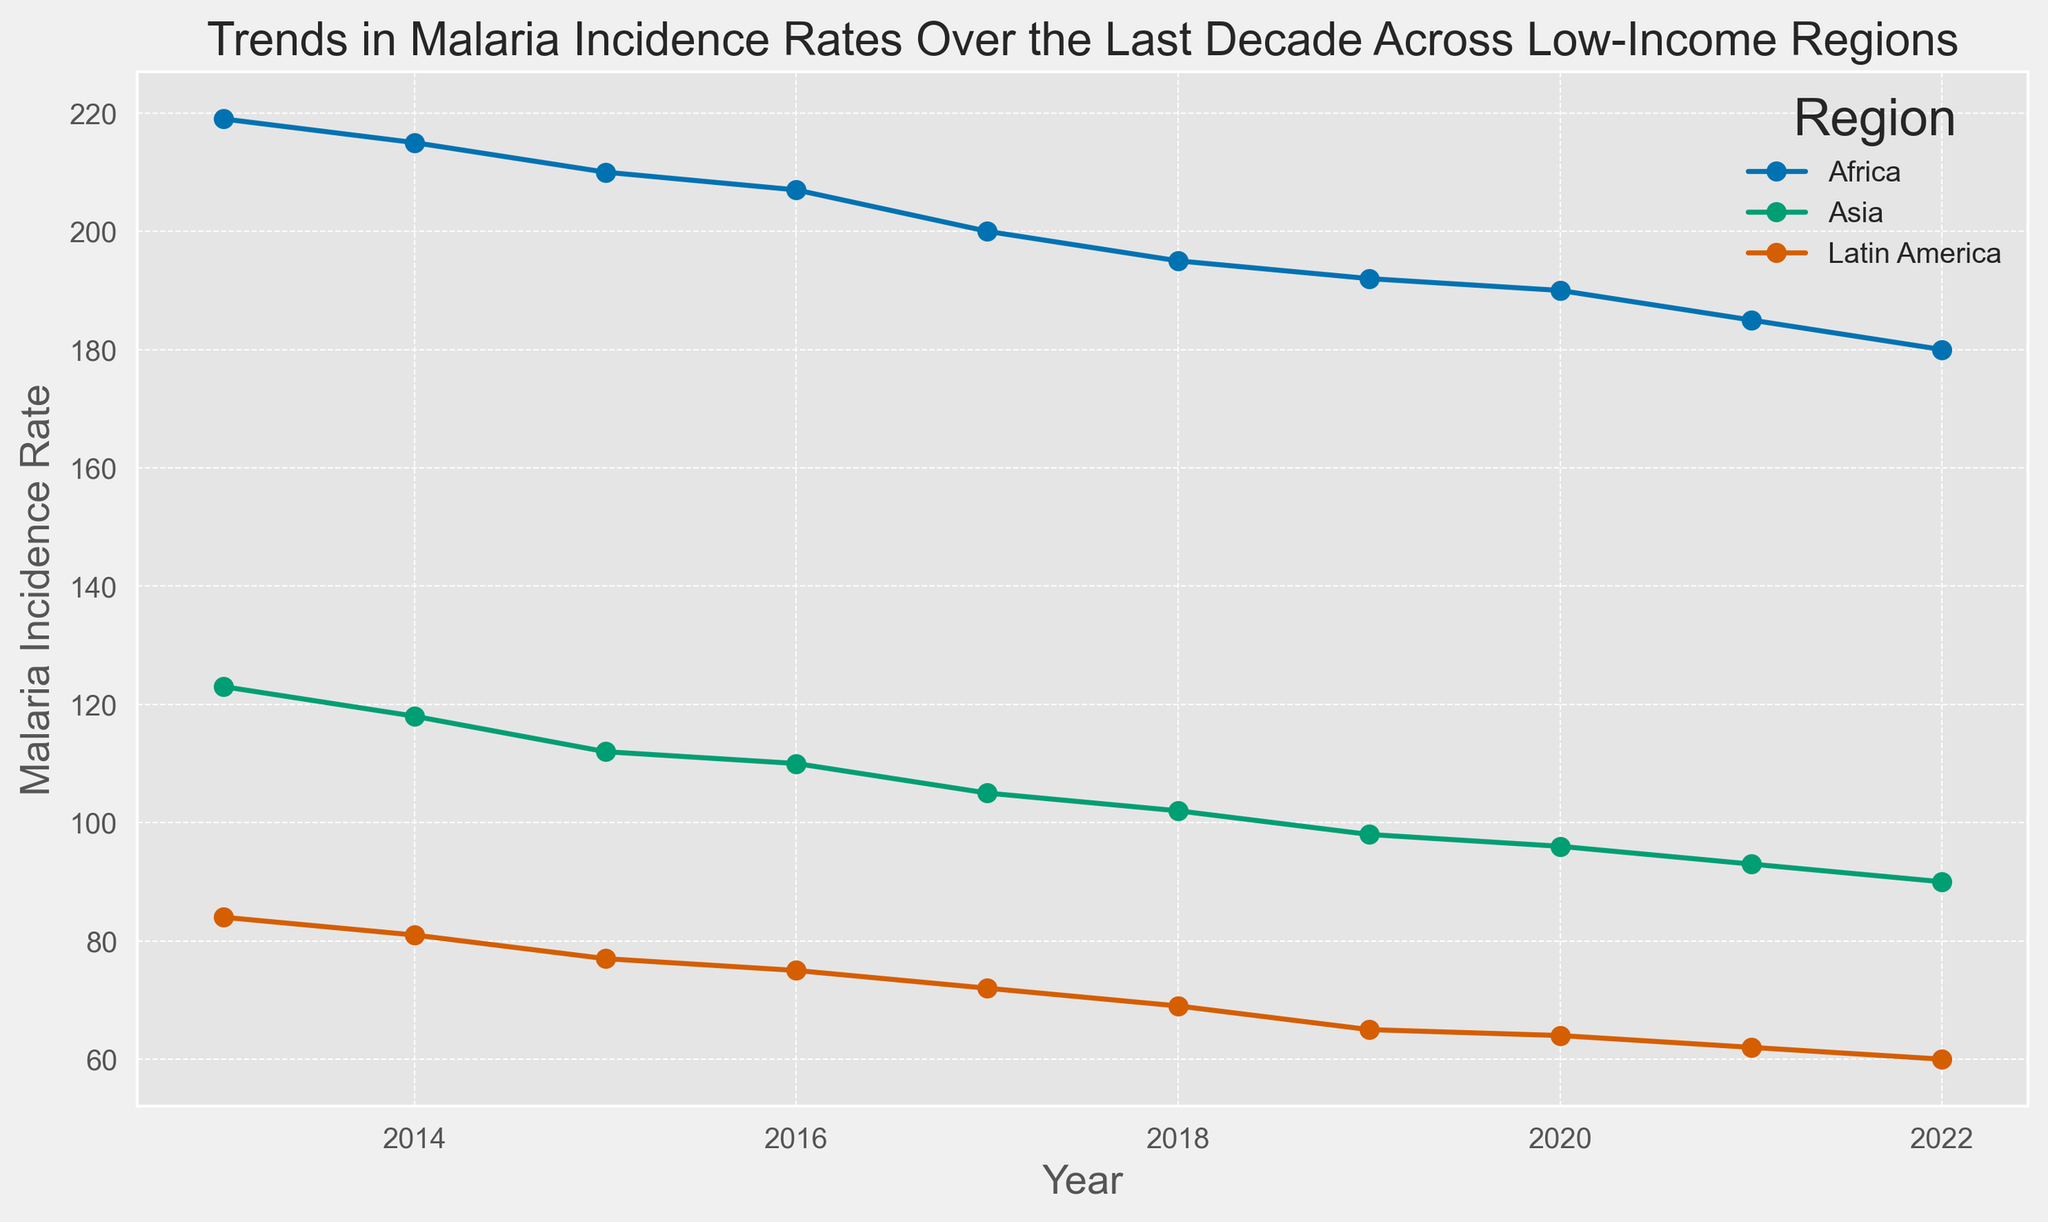Which region had the highest malaria incidence rate in 2013? By looking at the data for 2013, we see that Africa had an incidence rate of 219, which is higher than Asia's 123 and Latin America's 84.
Answer: Africa Between which consecutive years did Africa see the largest decrease in malaria incidence rate? By comparing the year-on-year changes, the largest drop is from 2014 (215) to 2015 (210), a decrease of 5 points.
Answer: 2014 to 2015 What was the average malaria incidence rate in Asia over the decade? Sum the incidence rates for Asia from 2013 to 2022 and divide by the number of years: (123 + 118 + 112 + 110 + 105 + 102 + 98 + 96 + 93 + 90) / 10 = 104.7.
Answer: 104.7 Which region showed the most consistent decline in malaria incidence rates over the decade? All regions have declining rates, but Asia's decrease follows a more consistent linear pattern compared to the others.
Answer: Asia In which year were the malaria incidence rates in Latin America and Asia closest to each other? By comparing the differences for each year, 2020 shows the smallest difference: 96 (Asia) - 64 (Latin America) = 32.
Answer: 2020 Which region showed the steepest decline in malaria incidence rate from 2018 to 2022? Calculate the change for each region: Africa (195 to 180 is -15), Asia (102 to 90 is -12), and Latin America (69 to 60 is -9). The steepest decline is in Africa.
Answer: Africa What is the total decline in malaria incidence rates in Latin America from 2013 to 2022? Subtract the 2022 incidence rate from the 2013 rate for Latin America: 84 - 60 = 24.
Answer: 24 Compare the rate of decline in malaria incidence between Asia and Africa over the decade. Which one had a steeper average annual decline? Calculate the total decline over the decade for both regions and divide by the number of years: Asia (123 - 90 = 33 over 10 years = 3.3 per year), Africa (219 - 180 = 39 over 10 years = 3.9 per year). Africa had a steeper average annual decline.
Answer: Africa Which region had the second-lowest malaria incidence rate in 2021? By looking at the 2021 data, Latin America had the lowest rate at 62, Africa had 185, and Asia had 93. Therefore, Asia had the second-lowest.
Answer: Asia How did the malaria incidence rate in Africa change from 2015 to 2017? The incidence rate in Africa decreased from 210 in 2015 to 200 in 2017, a decrease of 10.
Answer: Decreased by 10 